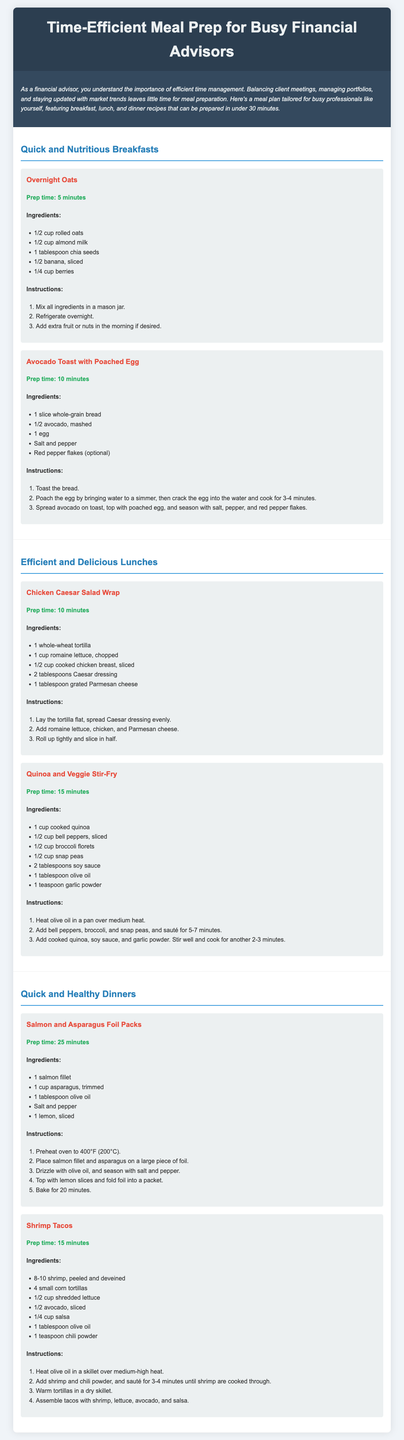What is the prep time for Overnight Oats? The prep time for Overnight Oats is mentioned in the document as 5 minutes.
Answer: 5 minutes What are the main ingredients in the Avocado Toast with Poached Egg? The main ingredients listed for Avocado Toast with Poached Egg are provided in the recipe section, which includes a slice of whole-grain bread, mashed avocado, and an egg.
Answer: Whole-grain bread, avocado, egg Which lunch recipe has a prep time of 10 minutes? The document specifies that the Chicken Caesar Salad Wrap has a prep time of 10 minutes, according to the recipe section.
Answer: Chicken Caesar Salad Wrap How many shrimp are needed for the shrimp tacos? The recipe for Shrimp Tacos states that 8-10 shrimp are required, based on the ingredients listed.
Answer: 8-10 shrimp What type of meal prep is this document designed for? The document is tailored for busy professionals, particularly financial advisors, emphasizing efficiency in meal preparation.
Answer: Busy professionals What is the total prep time for the Salmon and Asparagus Foil Packs? The Salmon and Asparagus Foil Packs has a prep time of 25 minutes as mentioned in the recipe section.
Answer: 25 minutes Which dinner recipe takes the least time to prepare? The Shrimp Tacos is the dinner recipe that takes 15 minutes to prepare, according to the document.
Answer: Shrimp Tacos What is a suggested addition to Overnight Oats in the morning? The document suggests adding extra fruit or nuts in the morning for the Overnight Oats recipe.
Answer: Extra fruit or nuts What seasoning is mentioned for the Salmon and Asparagus Foil Packs? The document lists salt and pepper as the seasonings for the Salmon and Asparagus Foil Packs recipe.
Answer: Salt and pepper 